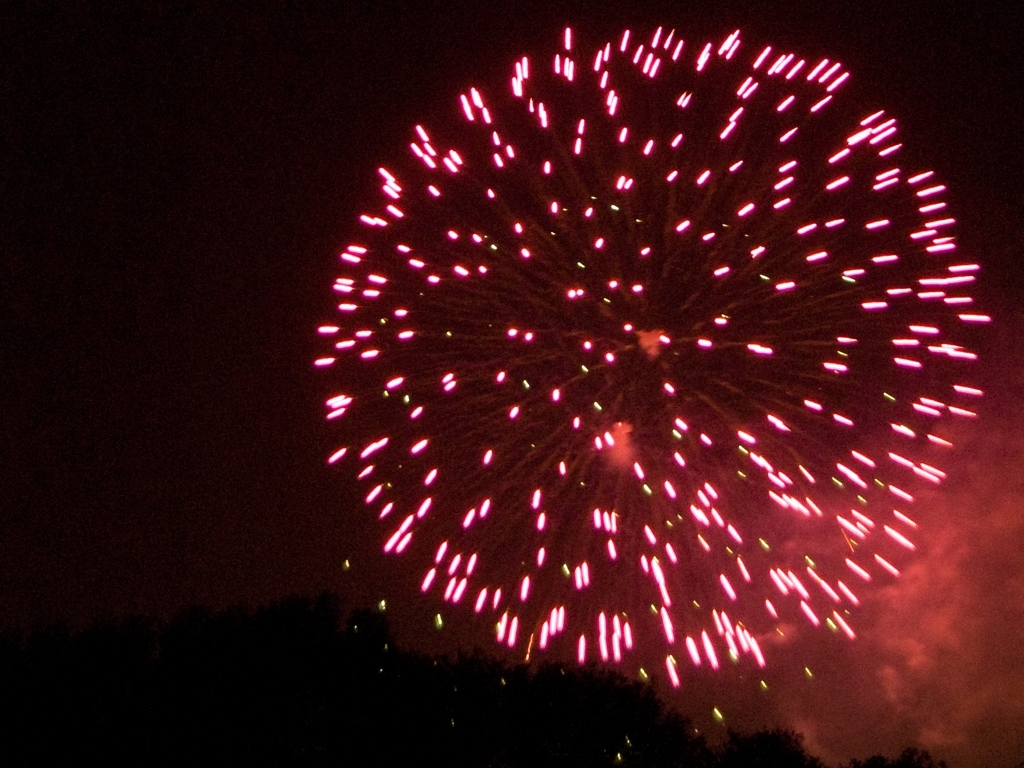What technical aspects might have been challenging while capturing this scene? Photographing fireworks can present numerous challenges. The photographer needs to manage several technical aspects such as exposure, focus, and timing. A slow shutter speed is required to capture the trajectory of the fireworks, which can result in motion blur if not handled correctly. Adjusting the aperture is also crucial to prevent overexposure due to the bright flashes. Additionally, setting the ISO too high can introduce noise, as is somewhat evident in the shadows of this image. To maximize sharpness and detail, a tripod is recommended to stabilize the camera and a remote shutter release to minimize camera shake. Capturing fireworks requires anticipation and often several attempts to get the timing just right. 